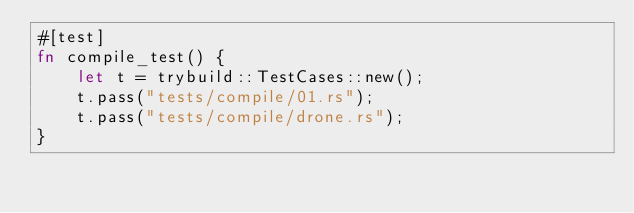<code> <loc_0><loc_0><loc_500><loc_500><_Rust_>#[test]
fn compile_test() {
    let t = trybuild::TestCases::new();
    t.pass("tests/compile/01.rs");
    t.pass("tests/compile/drone.rs");
}</code> 